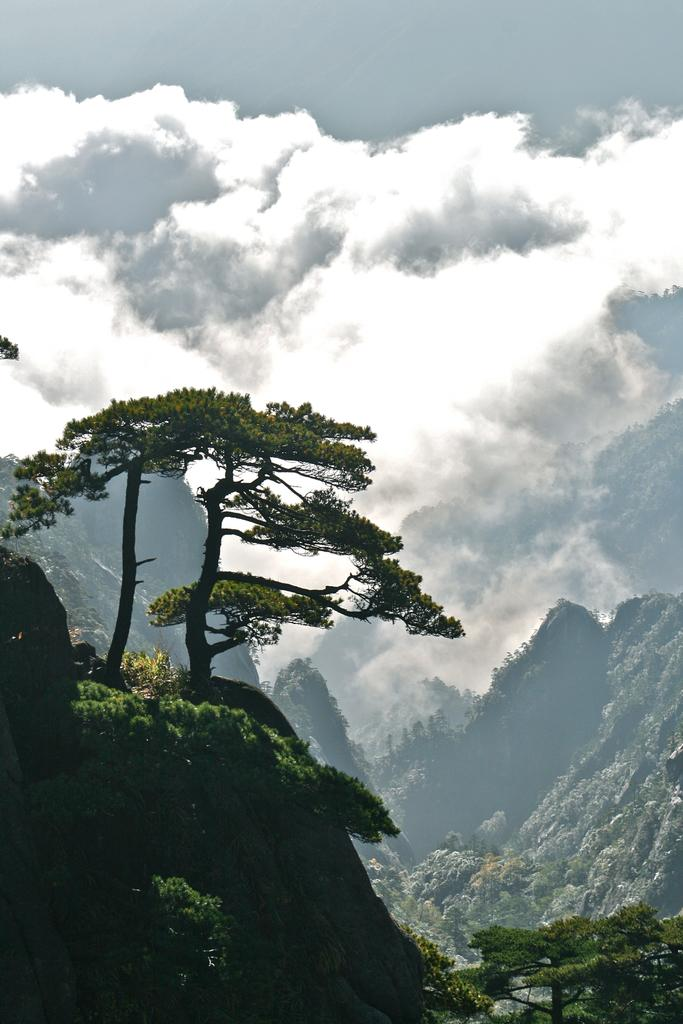What type of landscape feature is present in the image? There is a hill in the image. What covers the hill in the image? The hill is covered with trees. What can be seen behind the tree-covered hill? There are rock hills behind the tree-covered hill. What is the condition of the sky in the image? The sky is cloudy in the image. How many baskets are hanging from the trees on the hill? There are no baskets visible in the image; the hill is covered with trees, but no baskets are mentioned or depicted. 